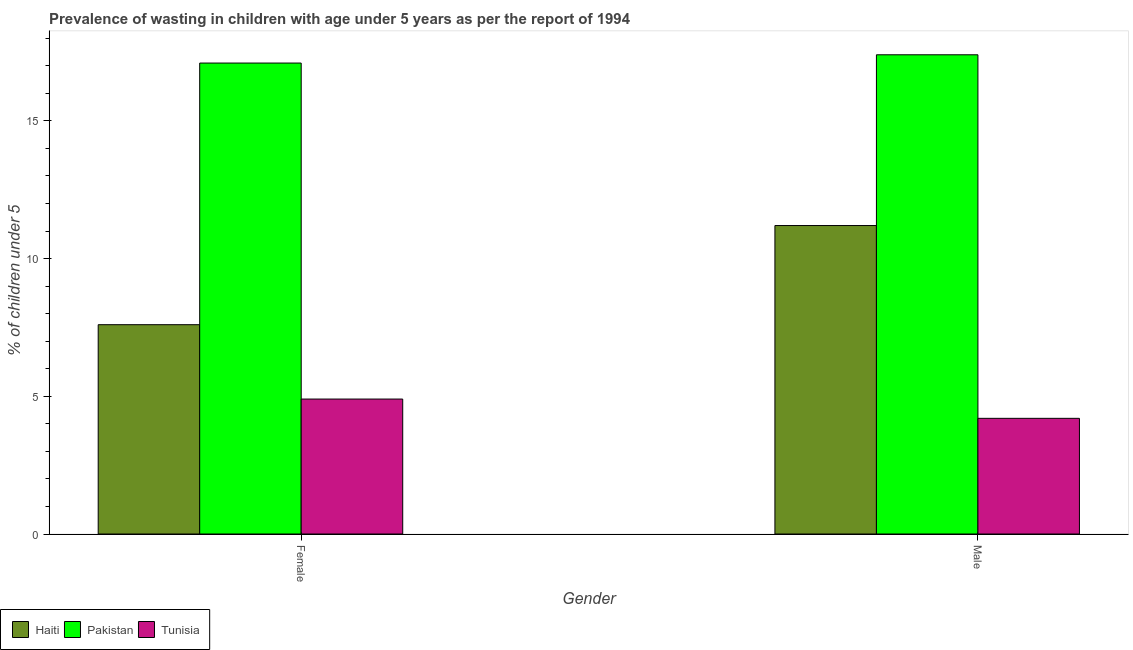How many different coloured bars are there?
Keep it short and to the point. 3. Are the number of bars per tick equal to the number of legend labels?
Give a very brief answer. Yes. Are the number of bars on each tick of the X-axis equal?
Offer a very short reply. Yes. How many bars are there on the 2nd tick from the left?
Give a very brief answer. 3. How many bars are there on the 2nd tick from the right?
Give a very brief answer. 3. What is the percentage of undernourished male children in Tunisia?
Give a very brief answer. 4.2. Across all countries, what is the maximum percentage of undernourished female children?
Your response must be concise. 17.1. Across all countries, what is the minimum percentage of undernourished male children?
Keep it short and to the point. 4.2. In which country was the percentage of undernourished male children minimum?
Ensure brevity in your answer.  Tunisia. What is the total percentage of undernourished male children in the graph?
Keep it short and to the point. 32.8. What is the difference between the percentage of undernourished male children in Haiti and that in Tunisia?
Your answer should be very brief. 7. What is the difference between the percentage of undernourished male children in Tunisia and the percentage of undernourished female children in Pakistan?
Make the answer very short. -12.9. What is the average percentage of undernourished female children per country?
Your answer should be very brief. 9.87. What is the difference between the percentage of undernourished male children and percentage of undernourished female children in Tunisia?
Your response must be concise. -0.7. In how many countries, is the percentage of undernourished female children greater than 12 %?
Give a very brief answer. 1. What is the ratio of the percentage of undernourished male children in Pakistan to that in Tunisia?
Provide a short and direct response. 4.14. Is the percentage of undernourished male children in Pakistan less than that in Haiti?
Make the answer very short. No. How many bars are there?
Keep it short and to the point. 6. How many countries are there in the graph?
Keep it short and to the point. 3. What is the difference between two consecutive major ticks on the Y-axis?
Give a very brief answer. 5. Where does the legend appear in the graph?
Offer a terse response. Bottom left. What is the title of the graph?
Keep it short and to the point. Prevalence of wasting in children with age under 5 years as per the report of 1994. Does "Uganda" appear as one of the legend labels in the graph?
Your answer should be very brief. No. What is the label or title of the X-axis?
Your answer should be very brief. Gender. What is the label or title of the Y-axis?
Your answer should be very brief.  % of children under 5. What is the  % of children under 5 in Haiti in Female?
Your answer should be compact. 7.6. What is the  % of children under 5 of Pakistan in Female?
Give a very brief answer. 17.1. What is the  % of children under 5 of Tunisia in Female?
Give a very brief answer. 4.9. What is the  % of children under 5 of Haiti in Male?
Provide a succinct answer. 11.2. What is the  % of children under 5 of Pakistan in Male?
Offer a very short reply. 17.4. What is the  % of children under 5 of Tunisia in Male?
Your answer should be compact. 4.2. Across all Gender, what is the maximum  % of children under 5 in Haiti?
Provide a succinct answer. 11.2. Across all Gender, what is the maximum  % of children under 5 of Pakistan?
Keep it short and to the point. 17.4. Across all Gender, what is the maximum  % of children under 5 of Tunisia?
Ensure brevity in your answer.  4.9. Across all Gender, what is the minimum  % of children under 5 in Haiti?
Your answer should be very brief. 7.6. Across all Gender, what is the minimum  % of children under 5 in Pakistan?
Ensure brevity in your answer.  17.1. Across all Gender, what is the minimum  % of children under 5 in Tunisia?
Keep it short and to the point. 4.2. What is the total  % of children under 5 of Haiti in the graph?
Ensure brevity in your answer.  18.8. What is the total  % of children under 5 of Pakistan in the graph?
Your response must be concise. 34.5. What is the total  % of children under 5 in Tunisia in the graph?
Make the answer very short. 9.1. What is the difference between the  % of children under 5 in Haiti in Female and the  % of children under 5 in Pakistan in Male?
Your answer should be compact. -9.8. What is the difference between the  % of children under 5 in Pakistan in Female and the  % of children under 5 in Tunisia in Male?
Provide a short and direct response. 12.9. What is the average  % of children under 5 in Pakistan per Gender?
Offer a terse response. 17.25. What is the average  % of children under 5 of Tunisia per Gender?
Give a very brief answer. 4.55. What is the difference between the  % of children under 5 of Haiti and  % of children under 5 of Tunisia in Female?
Your answer should be compact. 2.7. What is the difference between the  % of children under 5 of Haiti and  % of children under 5 of Tunisia in Male?
Ensure brevity in your answer.  7. What is the ratio of the  % of children under 5 in Haiti in Female to that in Male?
Offer a terse response. 0.68. What is the ratio of the  % of children under 5 in Pakistan in Female to that in Male?
Offer a very short reply. 0.98. What is the ratio of the  % of children under 5 in Tunisia in Female to that in Male?
Offer a terse response. 1.17. What is the difference between the highest and the second highest  % of children under 5 in Haiti?
Keep it short and to the point. 3.6. What is the difference between the highest and the second highest  % of children under 5 of Pakistan?
Your answer should be very brief. 0.3. What is the difference between the highest and the lowest  % of children under 5 in Tunisia?
Your answer should be compact. 0.7. 